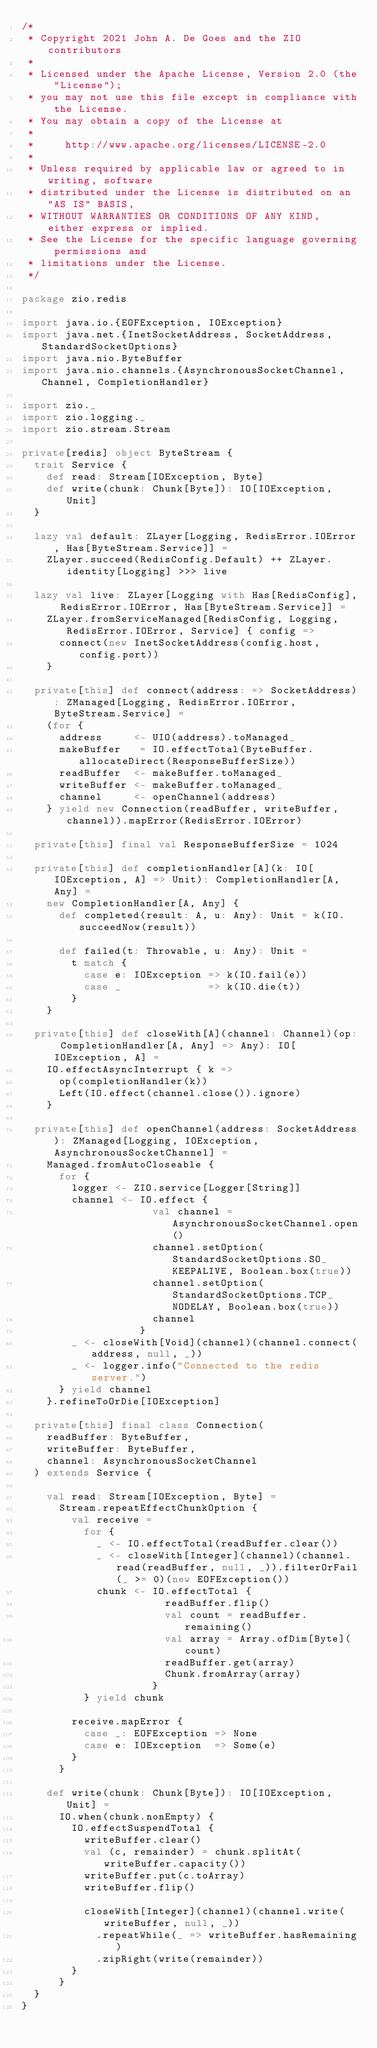Convert code to text. <code><loc_0><loc_0><loc_500><loc_500><_Scala_>/*
 * Copyright 2021 John A. De Goes and the ZIO contributors
 *
 * Licensed under the Apache License, Version 2.0 (the "License");
 * you may not use this file except in compliance with the License.
 * You may obtain a copy of the License at
 *
 *     http://www.apache.org/licenses/LICENSE-2.0
 *
 * Unless required by applicable law or agreed to in writing, software
 * distributed under the License is distributed on an "AS IS" BASIS,
 * WITHOUT WARRANTIES OR CONDITIONS OF ANY KIND, either express or implied.
 * See the License for the specific language governing permissions and
 * limitations under the License.
 */

package zio.redis

import java.io.{EOFException, IOException}
import java.net.{InetSocketAddress, SocketAddress, StandardSocketOptions}
import java.nio.ByteBuffer
import java.nio.channels.{AsynchronousSocketChannel, Channel, CompletionHandler}

import zio._
import zio.logging._
import zio.stream.Stream

private[redis] object ByteStream {
  trait Service {
    def read: Stream[IOException, Byte]
    def write(chunk: Chunk[Byte]): IO[IOException, Unit]
  }

  lazy val default: ZLayer[Logging, RedisError.IOError, Has[ByteStream.Service]] =
    ZLayer.succeed(RedisConfig.Default) ++ ZLayer.identity[Logging] >>> live

  lazy val live: ZLayer[Logging with Has[RedisConfig], RedisError.IOError, Has[ByteStream.Service]] =
    ZLayer.fromServiceManaged[RedisConfig, Logging, RedisError.IOError, Service] { config =>
      connect(new InetSocketAddress(config.host, config.port))
    }

  private[this] def connect(address: => SocketAddress): ZManaged[Logging, RedisError.IOError, ByteStream.Service] =
    (for {
      address     <- UIO(address).toManaged_
      makeBuffer   = IO.effectTotal(ByteBuffer.allocateDirect(ResponseBufferSize))
      readBuffer  <- makeBuffer.toManaged_
      writeBuffer <- makeBuffer.toManaged_
      channel     <- openChannel(address)
    } yield new Connection(readBuffer, writeBuffer, channel)).mapError(RedisError.IOError)

  private[this] final val ResponseBufferSize = 1024

  private[this] def completionHandler[A](k: IO[IOException, A] => Unit): CompletionHandler[A, Any] =
    new CompletionHandler[A, Any] {
      def completed(result: A, u: Any): Unit = k(IO.succeedNow(result))

      def failed(t: Throwable, u: Any): Unit =
        t match {
          case e: IOException => k(IO.fail(e))
          case _              => k(IO.die(t))
        }
    }

  private[this] def closeWith[A](channel: Channel)(op: CompletionHandler[A, Any] => Any): IO[IOException, A] =
    IO.effectAsyncInterrupt { k =>
      op(completionHandler(k))
      Left(IO.effect(channel.close()).ignore)
    }

  private[this] def openChannel(address: SocketAddress): ZManaged[Logging, IOException, AsynchronousSocketChannel] =
    Managed.fromAutoCloseable {
      for {
        logger <- ZIO.service[Logger[String]]
        channel <- IO.effect {
                     val channel = AsynchronousSocketChannel.open()
                     channel.setOption(StandardSocketOptions.SO_KEEPALIVE, Boolean.box(true))
                     channel.setOption(StandardSocketOptions.TCP_NODELAY, Boolean.box(true))
                     channel
                   }
        _ <- closeWith[Void](channel)(channel.connect(address, null, _))
        _ <- logger.info("Connected to the redis server.")
      } yield channel
    }.refineToOrDie[IOException]

  private[this] final class Connection(
    readBuffer: ByteBuffer,
    writeBuffer: ByteBuffer,
    channel: AsynchronousSocketChannel
  ) extends Service {

    val read: Stream[IOException, Byte] =
      Stream.repeatEffectChunkOption {
        val receive =
          for {
            _ <- IO.effectTotal(readBuffer.clear())
            _ <- closeWith[Integer](channel)(channel.read(readBuffer, null, _)).filterOrFail(_ >= 0)(new EOFException())
            chunk <- IO.effectTotal {
                       readBuffer.flip()
                       val count = readBuffer.remaining()
                       val array = Array.ofDim[Byte](count)
                       readBuffer.get(array)
                       Chunk.fromArray(array)
                     }
          } yield chunk

        receive.mapError {
          case _: EOFException => None
          case e: IOException  => Some(e)
        }
      }

    def write(chunk: Chunk[Byte]): IO[IOException, Unit] =
      IO.when(chunk.nonEmpty) {
        IO.effectSuspendTotal {
          writeBuffer.clear()
          val (c, remainder) = chunk.splitAt(writeBuffer.capacity())
          writeBuffer.put(c.toArray)
          writeBuffer.flip()

          closeWith[Integer](channel)(channel.write(writeBuffer, null, _))
            .repeatWhile(_ => writeBuffer.hasRemaining)
            .zipRight(write(remainder))
        }
      }
  }
}
</code> 